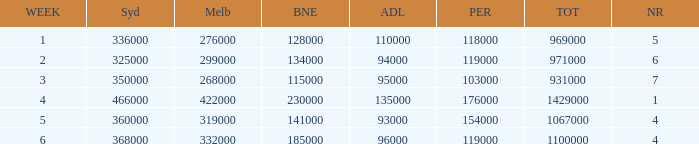What was the total rating on week 3?  931000.0. 